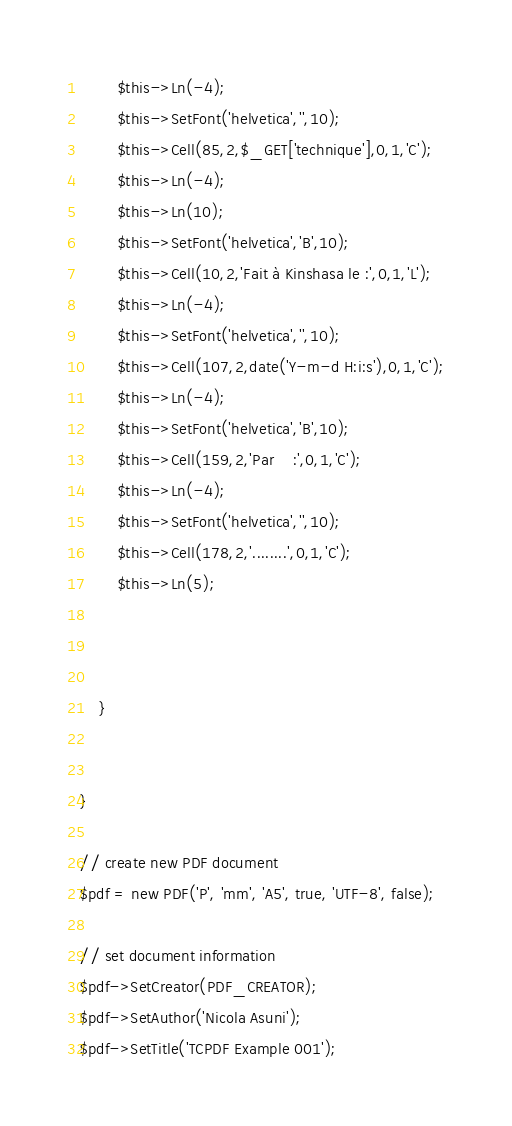<code> <loc_0><loc_0><loc_500><loc_500><_PHP_>        $this->Ln(-4);
        $this->SetFont('helvetica','',10);
        $this->Cell(85,2,$_GET['technique'],0,1,'C');
        $this->Ln(-4);
        $this->Ln(10);
        $this->SetFont('helvetica','B',10);
        $this->Cell(10,2,'Fait à Kinshasa le :',0,1,'L');
        $this->Ln(-4);
        $this->SetFont('helvetica','',10);
        $this->Cell(107,2,date('Y-m-d H:i:s'),0,1,'C');
        $this->Ln(-4);
        $this->SetFont('helvetica','B',10);
        $this->Cell(159,2,'Par    :',0,1,'C');
        $this->Ln(-4);
        $this->SetFont('helvetica','',10);
        $this->Cell(178,2,'........',0,1,'C');
        $this->Ln(5);
        

        
    }

  
}

// create new PDF document
$pdf = new PDF('P', 'mm', 'A5', true, 'UTF-8', false);

// set document information
$pdf->SetCreator(PDF_CREATOR);
$pdf->SetAuthor('Nicola Asuni');
$pdf->SetTitle('TCPDF Example 001');</code> 